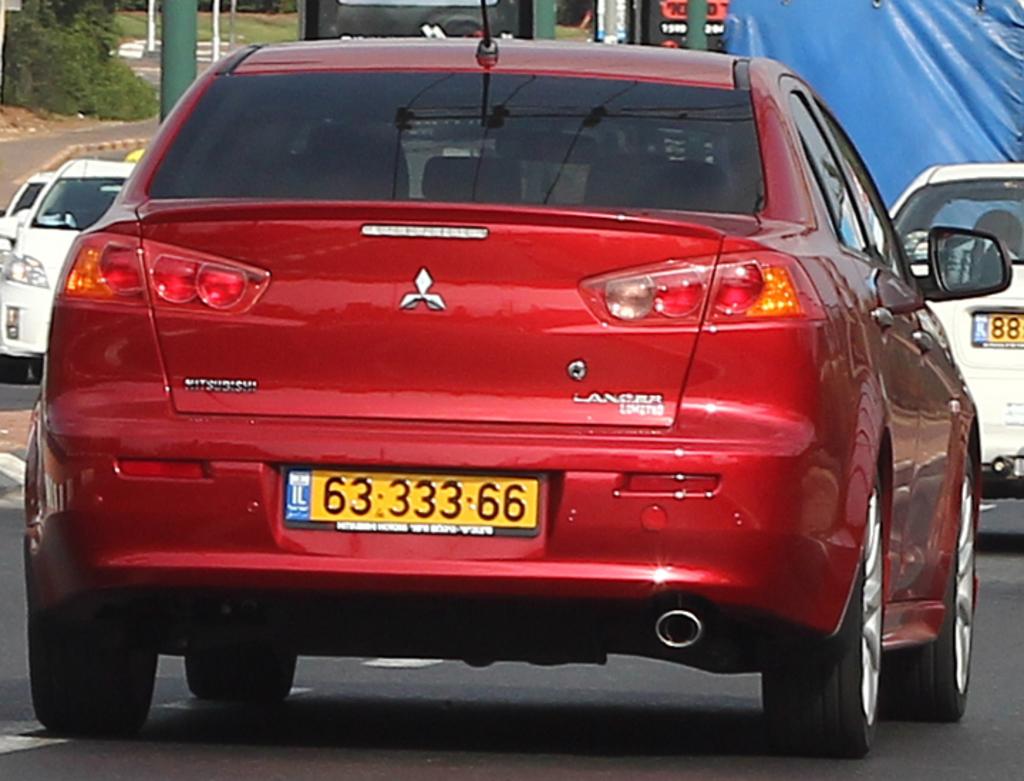What brand is this car?
Your answer should be very brief. Mitsubishi. What is the license plate number of the red car?
Keep it short and to the point. 63 333 66. 